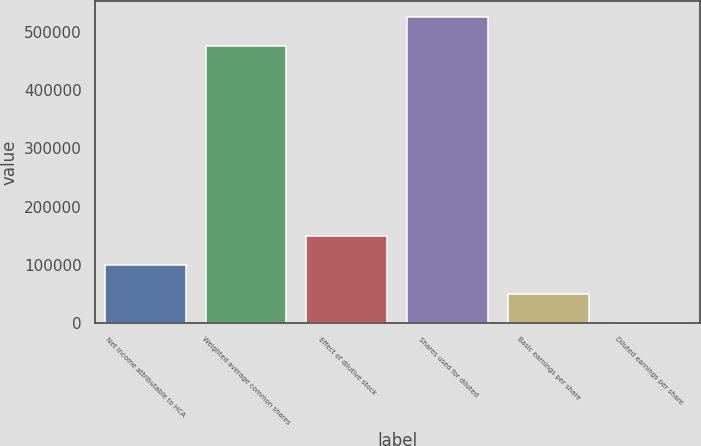<chart> <loc_0><loc_0><loc_500><loc_500><bar_chart><fcel>Net income attributable to HCA<fcel>Weighted average common shares<fcel>Effect of dilutive stock<fcel>Shares used for diluted<fcel>Basic earnings per share<fcel>Diluted earnings per share<nl><fcel>99192.6<fcel>476609<fcel>148786<fcel>526203<fcel>49598.8<fcel>4.97<nl></chart> 